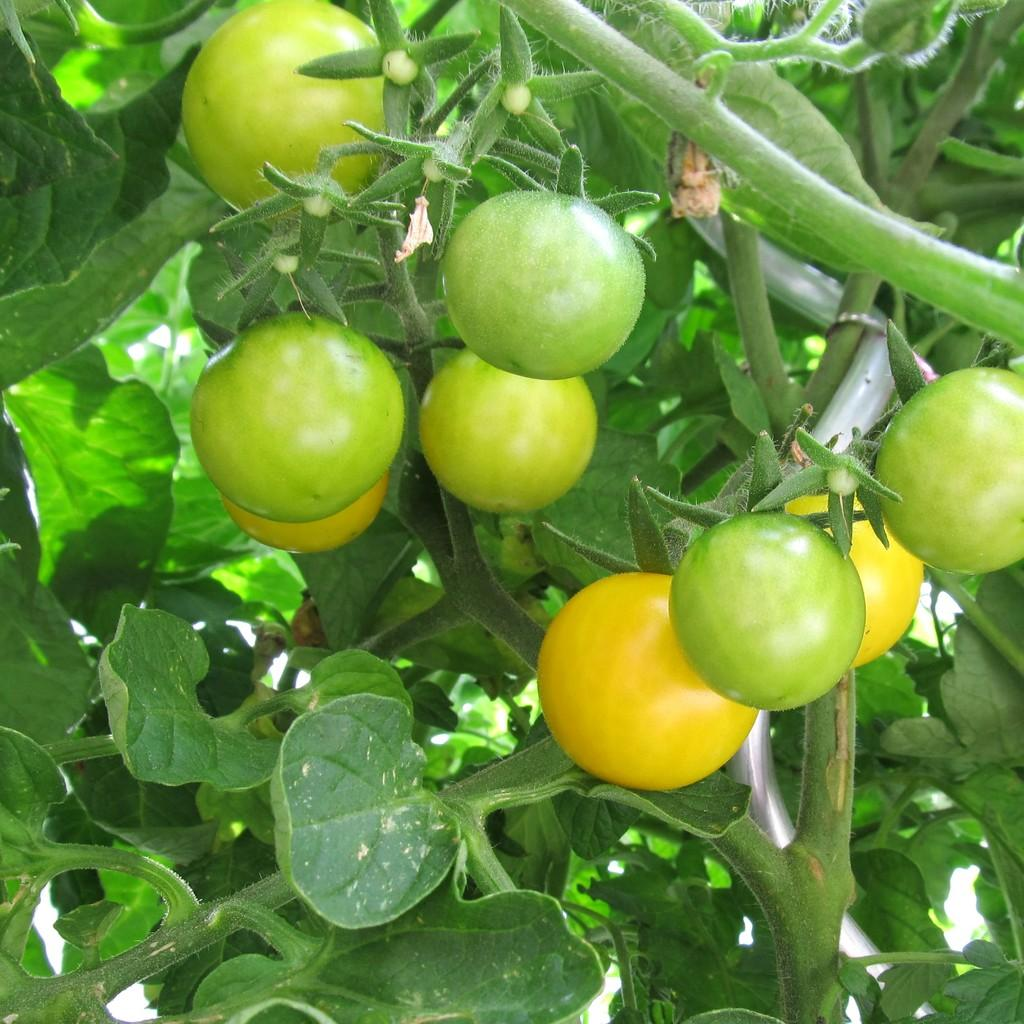What is the main subject of the image? The main subject of the image is planets. What is unique about these planets? These planets contain vegetables. Can you describe the appearance of the vegetables? The vegetables are green and yellow in color. What type of flag is being waved by the grandmother in the image? There is no flag or grandmother present in the image; it features planets with vegetables. 